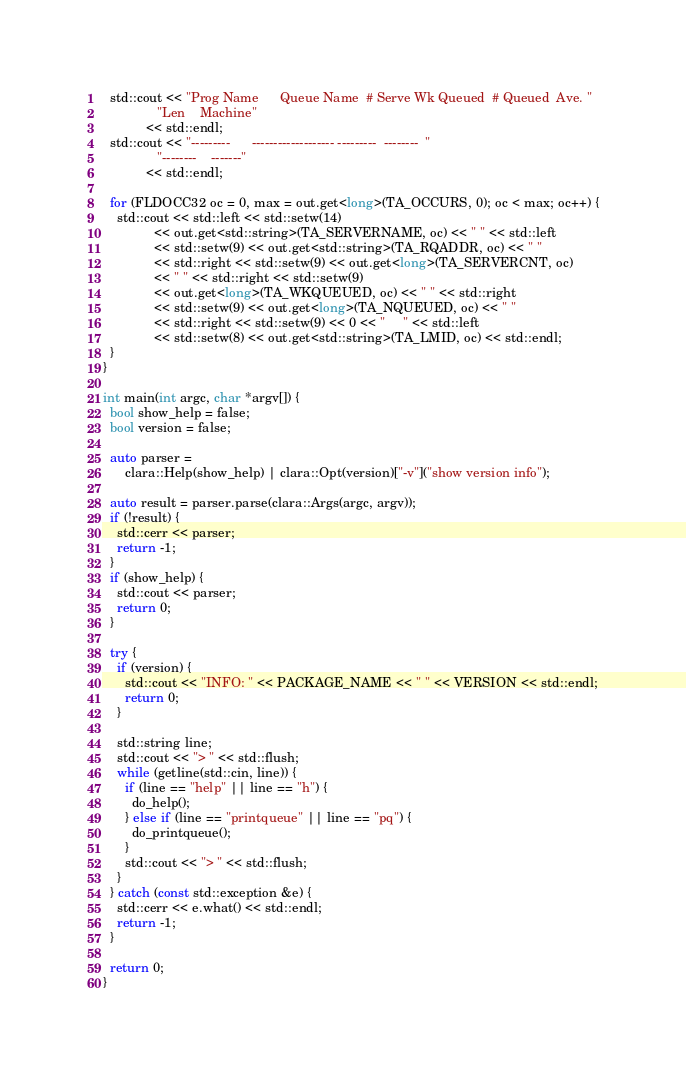<code> <loc_0><loc_0><loc_500><loc_500><_C++_>  std::cout << "Prog Name      Queue Name  # Serve Wk Queued  # Queued  Ave. "
               "Len    Machine"
            << std::endl;
  std::cout << "---------      ------------------- ---------  --------  "
               "--------    -------"
            << std::endl;

  for (FLDOCC32 oc = 0, max = out.get<long>(TA_OCCURS, 0); oc < max; oc++) {
    std::cout << std::left << std::setw(14)
              << out.get<std::string>(TA_SERVERNAME, oc) << " " << std::left
              << std::setw(9) << out.get<std::string>(TA_RQADDR, oc) << " "
              << std::right << std::setw(9) << out.get<long>(TA_SERVERCNT, oc)
              << " " << std::right << std::setw(9)
              << out.get<long>(TA_WKQUEUED, oc) << " " << std::right
              << std::setw(9) << out.get<long>(TA_NQUEUED, oc) << " "
              << std::right << std::setw(9) << 0 << "     " << std::left
              << std::setw(8) << out.get<std::string>(TA_LMID, oc) << std::endl;
  }
}

int main(int argc, char *argv[]) {
  bool show_help = false;
  bool version = false;

  auto parser =
      clara::Help(show_help) | clara::Opt(version)["-v"]("show version info");

  auto result = parser.parse(clara::Args(argc, argv));
  if (!result) {
    std::cerr << parser;
    return -1;
  }
  if (show_help) {
    std::cout << parser;
    return 0;
  }

  try {
    if (version) {
      std::cout << "INFO: " << PACKAGE_NAME << " " << VERSION << std::endl;
      return 0;
    }

    std::string line;
    std::cout << "> " << std::flush;
    while (getline(std::cin, line)) {
      if (line == "help" || line == "h") {
        do_help();
      } else if (line == "printqueue" || line == "pq") {
        do_printqueue();
      }
      std::cout << "> " << std::flush;
    }
  } catch (const std::exception &e) {
    std::cerr << e.what() << std::endl;
    return -1;
  }

  return 0;
}
</code> 